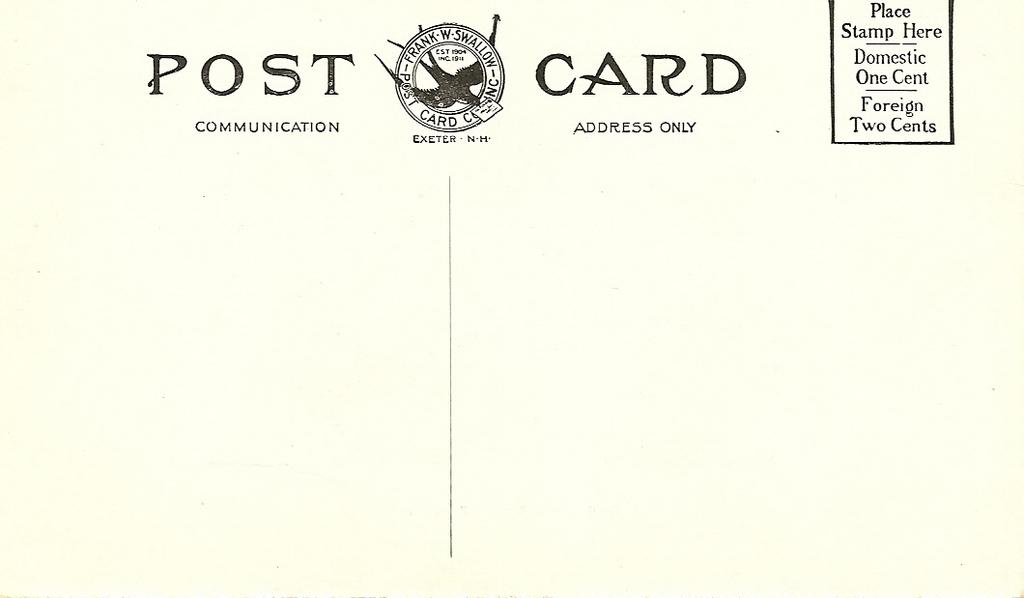Provide a one-sentence caption for the provided image. Post card that is empty and needs a stamp to place on the right side. 